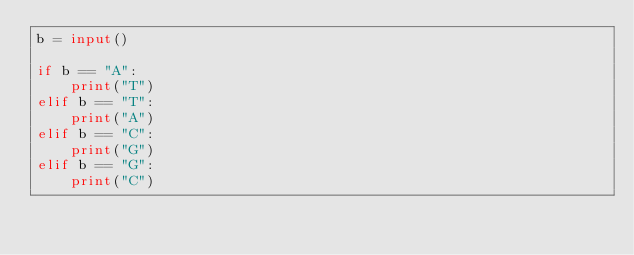Convert code to text. <code><loc_0><loc_0><loc_500><loc_500><_Python_>b = input()

if b == "A":
    print("T")
elif b == "T":
    print("A")
elif b == "C":
    print("G")
elif b == "G":
    print("C")</code> 